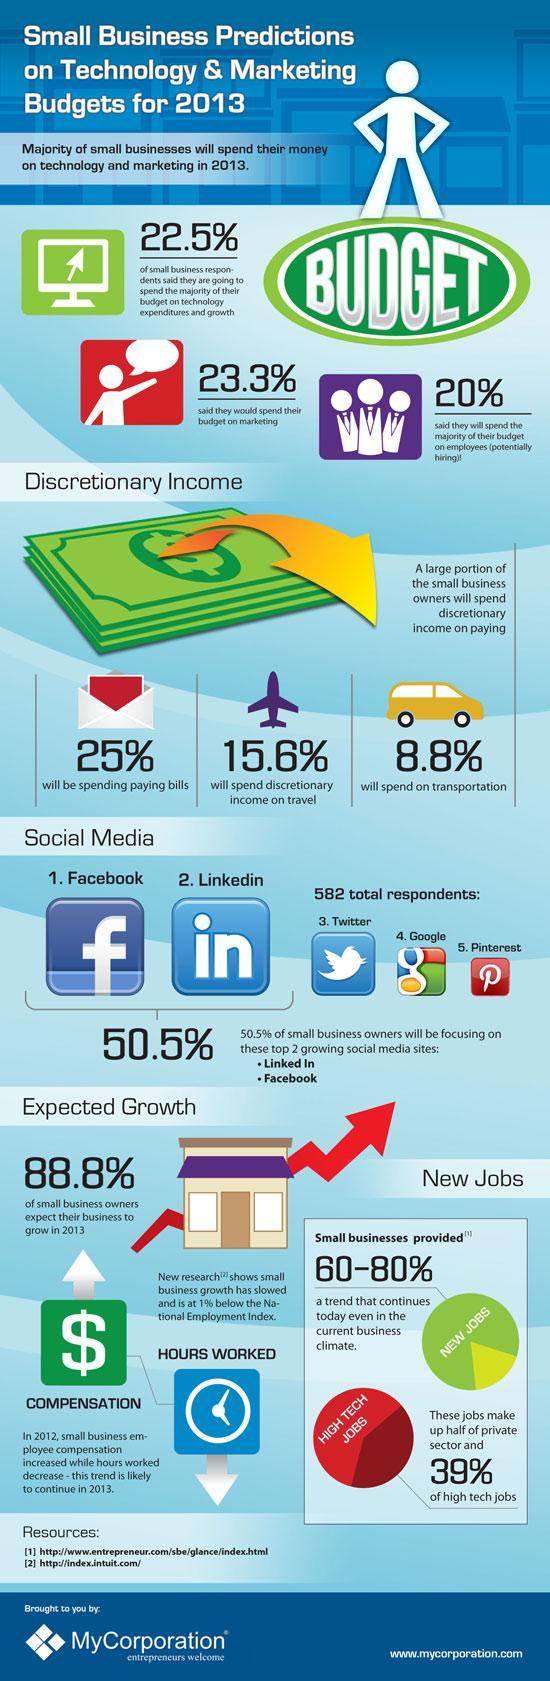Specify some key components in this picture. The majority of respondents are spending their discretionary income on paying bills, indicating a significant portion of their income is being allocated towards necessary expenses. There are 5 social media platforms mentioned in this text. Pinterest is the social media site represented by the letter 'P'. A survey conducted in 2013 revealed that a staggering 88.8% of small business owners expected their business to grow. According to the survey, 22.5% of the respondents intend to allocate the majority of their budget towards technology. 